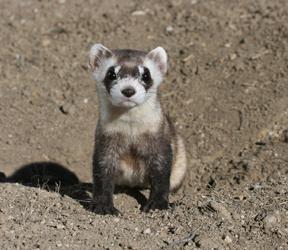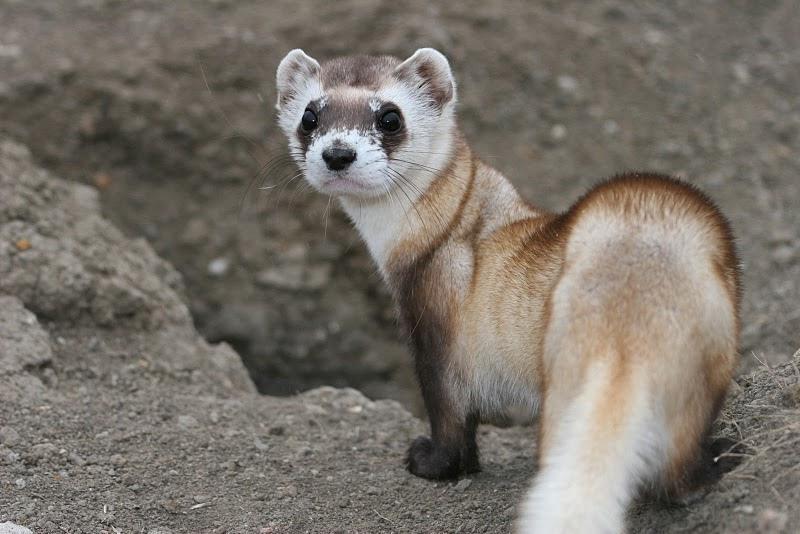The first image is the image on the left, the second image is the image on the right. Analyze the images presented: Is the assertion "A total of four ferrets are shown, all sticking their heads up above the surface of the ground." valid? Answer yes or no. No. The first image is the image on the left, the second image is the image on the right. Evaluate the accuracy of this statement regarding the images: "There are exactly 4 animals.". Is it true? Answer yes or no. No. 